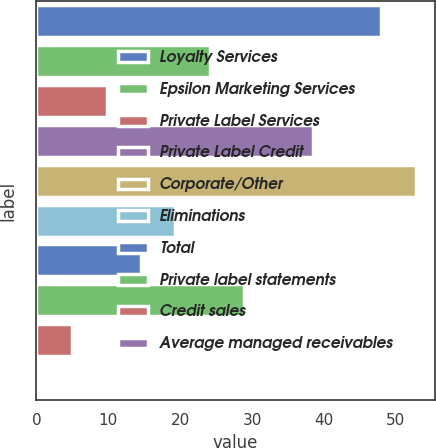<chart> <loc_0><loc_0><loc_500><loc_500><bar_chart><fcel>Loyalty Services<fcel>Epsilon Marketing Services<fcel>Private Label Services<fcel>Private Label Credit<fcel>Corporate/Other<fcel>Eliminations<fcel>Total<fcel>Private label statements<fcel>Credit sales<fcel>Average managed receivables<nl><fcel>48<fcel>24.1<fcel>9.76<fcel>38.44<fcel>52.78<fcel>19.32<fcel>14.54<fcel>28.88<fcel>4.98<fcel>0.2<nl></chart> 